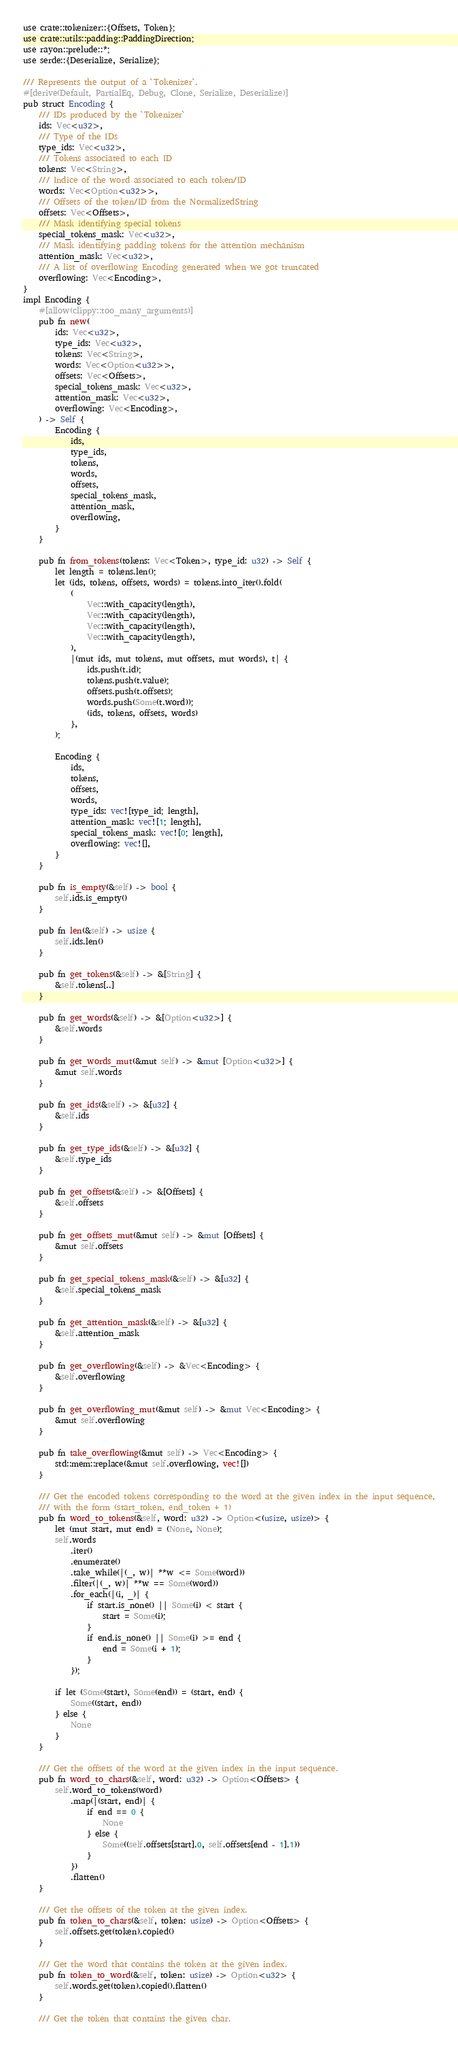<code> <loc_0><loc_0><loc_500><loc_500><_Rust_>use crate::tokenizer::{Offsets, Token};
use crate::utils::padding::PaddingDirection;
use rayon::prelude::*;
use serde::{Deserialize, Serialize};

/// Represents the output of a `Tokenizer`.
#[derive(Default, PartialEq, Debug, Clone, Serialize, Deserialize)]
pub struct Encoding {
    /// IDs produced by the `Tokenizer`
    ids: Vec<u32>,
    /// Type of the IDs
    type_ids: Vec<u32>,
    /// Tokens associated to each ID
    tokens: Vec<String>,
    /// Indice of the word associated to each token/ID
    words: Vec<Option<u32>>,
    /// Offsets of the token/ID from the NormalizedString
    offsets: Vec<Offsets>,
    /// Mask identifying special tokens
    special_tokens_mask: Vec<u32>,
    /// Mask identifying padding tokens for the attention mechanism
    attention_mask: Vec<u32>,
    /// A list of overflowing Encoding generated when we got truncated
    overflowing: Vec<Encoding>,
}
impl Encoding {
    #[allow(clippy::too_many_arguments)]
    pub fn new(
        ids: Vec<u32>,
        type_ids: Vec<u32>,
        tokens: Vec<String>,
        words: Vec<Option<u32>>,
        offsets: Vec<Offsets>,
        special_tokens_mask: Vec<u32>,
        attention_mask: Vec<u32>,
        overflowing: Vec<Encoding>,
    ) -> Self {
        Encoding {
            ids,
            type_ids,
            tokens,
            words,
            offsets,
            special_tokens_mask,
            attention_mask,
            overflowing,
        }
    }

    pub fn from_tokens(tokens: Vec<Token>, type_id: u32) -> Self {
        let length = tokens.len();
        let (ids, tokens, offsets, words) = tokens.into_iter().fold(
            (
                Vec::with_capacity(length),
                Vec::with_capacity(length),
                Vec::with_capacity(length),
                Vec::with_capacity(length),
            ),
            |(mut ids, mut tokens, mut offsets, mut words), t| {
                ids.push(t.id);
                tokens.push(t.value);
                offsets.push(t.offsets);
                words.push(Some(t.word));
                (ids, tokens, offsets, words)
            },
        );

        Encoding {
            ids,
            tokens,
            offsets,
            words,
            type_ids: vec![type_id; length],
            attention_mask: vec![1; length],
            special_tokens_mask: vec![0; length],
            overflowing: vec![],
        }
    }

    pub fn is_empty(&self) -> bool {
        self.ids.is_empty()
    }

    pub fn len(&self) -> usize {
        self.ids.len()
    }

    pub fn get_tokens(&self) -> &[String] {
        &self.tokens[..]
    }

    pub fn get_words(&self) -> &[Option<u32>] {
        &self.words
    }

    pub fn get_words_mut(&mut self) -> &mut [Option<u32>] {
        &mut self.words
    }

    pub fn get_ids(&self) -> &[u32] {
        &self.ids
    }

    pub fn get_type_ids(&self) -> &[u32] {
        &self.type_ids
    }

    pub fn get_offsets(&self) -> &[Offsets] {
        &self.offsets
    }

    pub fn get_offsets_mut(&mut self) -> &mut [Offsets] {
        &mut self.offsets
    }

    pub fn get_special_tokens_mask(&self) -> &[u32] {
        &self.special_tokens_mask
    }

    pub fn get_attention_mask(&self) -> &[u32] {
        &self.attention_mask
    }

    pub fn get_overflowing(&self) -> &Vec<Encoding> {
        &self.overflowing
    }

    pub fn get_overflowing_mut(&mut self) -> &mut Vec<Encoding> {
        &mut self.overflowing
    }

    pub fn take_overflowing(&mut self) -> Vec<Encoding> {
        std::mem::replace(&mut self.overflowing, vec![])
    }

    /// Get the encoded tokens corresponding to the word at the given index in the input sequence,
    /// with the form (start_token, end_token + 1)
    pub fn word_to_tokens(&self, word: u32) -> Option<(usize, usize)> {
        let (mut start, mut end) = (None, None);
        self.words
            .iter()
            .enumerate()
            .take_while(|(_, w)| **w <= Some(word))
            .filter(|(_, w)| **w == Some(word))
            .for_each(|(i, _)| {
                if start.is_none() || Some(i) < start {
                    start = Some(i);
                }
                if end.is_none() || Some(i) >= end {
                    end = Some(i + 1);
                }
            });

        if let (Some(start), Some(end)) = (start, end) {
            Some((start, end))
        } else {
            None
        }
    }

    /// Get the offsets of the word at the given index in the input sequence.
    pub fn word_to_chars(&self, word: u32) -> Option<Offsets> {
        self.word_to_tokens(word)
            .map(|(start, end)| {
                if end == 0 {
                    None
                } else {
                    Some((self.offsets[start].0, self.offsets[end - 1].1))
                }
            })
            .flatten()
    }

    /// Get the offsets of the token at the given index.
    pub fn token_to_chars(&self, token: usize) -> Option<Offsets> {
        self.offsets.get(token).copied()
    }

    /// Get the word that contains the token at the given index.
    pub fn token_to_word(&self, token: usize) -> Option<u32> {
        self.words.get(token).copied().flatten()
    }

    /// Get the token that contains the given char.</code> 